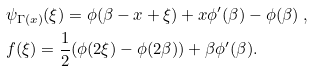Convert formula to latex. <formula><loc_0><loc_0><loc_500><loc_500>& \psi _ { \Gamma ( x ) } ( \xi ) = \phi ( \beta - x + \xi ) + x \phi ^ { \prime } ( \beta ) - \phi ( \beta ) \ , \\ & f ( \xi ) = \frac { 1 } { 2 } ( \phi ( 2 \xi ) - \phi ( 2 \beta ) ) + \beta \phi ^ { \prime } ( \beta ) .</formula> 